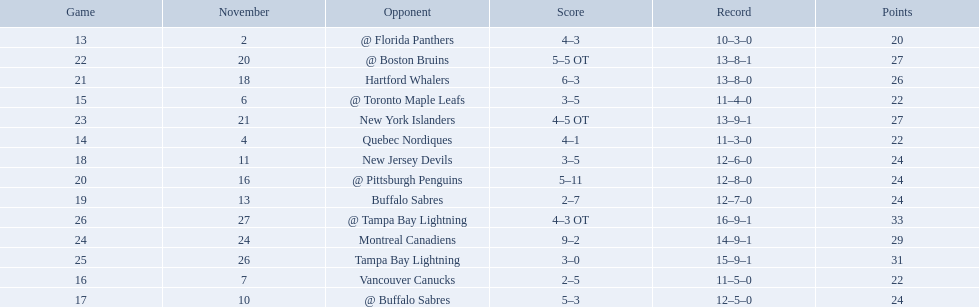What are the teams in the atlantic division? Quebec Nordiques, Vancouver Canucks, New Jersey Devils, Buffalo Sabres, Hartford Whalers, New York Islanders, Montreal Canadiens, Tampa Bay Lightning. Help me parse the entirety of this table. {'header': ['Game', 'November', 'Opponent', 'Score', 'Record', 'Points'], 'rows': [['13', '2', '@ Florida Panthers', '4–3', '10–3–0', '20'], ['22', '20', '@ Boston Bruins', '5–5 OT', '13–8–1', '27'], ['21', '18', 'Hartford Whalers', '6–3', '13–8–0', '26'], ['15', '6', '@ Toronto Maple Leafs', '3–5', '11–4–0', '22'], ['23', '21', 'New York Islanders', '4–5 OT', '13–9–1', '27'], ['14', '4', 'Quebec Nordiques', '4–1', '11–3–0', '22'], ['18', '11', 'New Jersey Devils', '3–5', '12–6–0', '24'], ['20', '16', '@ Pittsburgh Penguins', '5–11', '12–8–0', '24'], ['19', '13', 'Buffalo Sabres', '2–7', '12–7–0', '24'], ['26', '27', '@ Tampa Bay Lightning', '4–3 OT', '16–9–1', '33'], ['24', '24', 'Montreal Canadiens', '9–2', '14–9–1', '29'], ['25', '26', 'Tampa Bay Lightning', '3–0', '15–9–1', '31'], ['16', '7', 'Vancouver Canucks', '2–5', '11–5–0', '22'], ['17', '10', '@ Buffalo Sabres', '5–3', '12–5–0', '24']]} Which of those scored fewer points than the philadelphia flyers? Tampa Bay Lightning. 